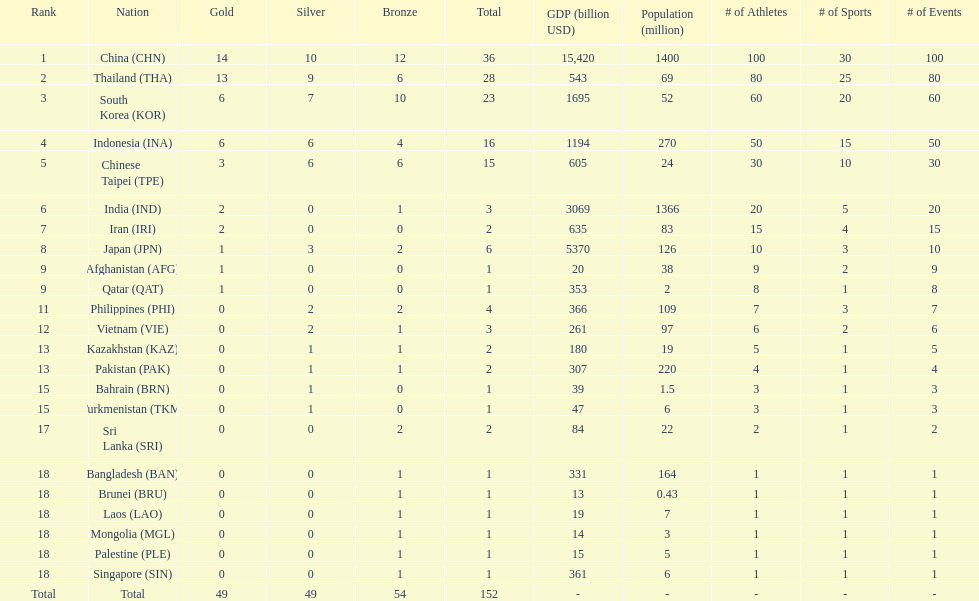Did the philippines or kazakhstan have a higher number of total medals? Philippines. Can you give me this table as a dict? {'header': ['Rank', 'Nation', 'Gold', 'Silver', 'Bronze', 'Total', 'GDP (billion USD)', 'Population (million)', '# of Athletes', '# of Sports', '# of Events'], 'rows': [['1', 'China\xa0(CHN)', '14', '10', '12', '36', '15,420', '1400', '100', '30', '100'], ['2', 'Thailand\xa0(THA)', '13', '9', '6', '28', '543', '69', '80', '25', '80'], ['3', 'South Korea\xa0(KOR)', '6', '7', '10', '23', '1695', '52', '60', '20', '60'], ['4', 'Indonesia\xa0(INA)', '6', '6', '4', '16', '1194', '270', '50', '15', '50'], ['5', 'Chinese Taipei\xa0(TPE)', '3', '6', '6', '15', '605', '24', '30', '10', '30'], ['6', 'India\xa0(IND)', '2', '0', '1', '3', '3069', '1366', '20', '5', '20'], ['7', 'Iran\xa0(IRI)', '2', '0', '0', '2', '635', '83', '15', '4', '15'], ['8', 'Japan\xa0(JPN)', '1', '3', '2', '6', '5370', '126', '10', '3', '10'], ['9', 'Afghanistan\xa0(AFG)', '1', '0', '0', '1', '20', '38', '9', '2', '9'], ['9', 'Qatar\xa0(QAT)', '1', '0', '0', '1', '353', '2', '8', '1', '8'], ['11', 'Philippines\xa0(PHI)', '0', '2', '2', '4', '366', '109', '7', '3', '7'], ['12', 'Vietnam\xa0(VIE)', '0', '2', '1', '3', '261', '97', '6', '2', '6'], ['13', 'Kazakhstan\xa0(KAZ)', '0', '1', '1', '2', '180', '19', '5', '1', '5'], ['13', 'Pakistan\xa0(PAK)', '0', '1', '1', '2', '307', '220', '4', '1', '4'], ['15', 'Bahrain\xa0(BRN)', '0', '1', '0', '1', '39', '1.5', '3', '1', '3'], ['15', 'Turkmenistan\xa0(TKM)', '0', '1', '0', '1', '47', '6', '3', '1', '3'], ['17', 'Sri Lanka\xa0(SRI)', '0', '0', '2', '2', '84', '22', '2', '1', '2'], ['18', 'Bangladesh\xa0(BAN)', '0', '0', '1', '1', '331', '164', '1', '1', '1'], ['18', 'Brunei\xa0(BRU)', '0', '0', '1', '1', '13', '0.43', '1', '1', '1'], ['18', 'Laos\xa0(LAO)', '0', '0', '1', '1', '19', '7', '1', '1', '1'], ['18', 'Mongolia\xa0(MGL)', '0', '0', '1', '1', '14', '3', '1', '1', '1'], ['18', 'Palestine\xa0(PLE)', '0', '0', '1', '1', '15', '5', '1', '1', '1'], ['18', 'Singapore\xa0(SIN)', '0', '0', '1', '1', '361', '6', '1', '1', '1'], ['Total', 'Total', '49', '49', '54', '152', '-', '-', '-', '-', '-']]} 